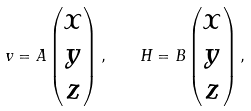<formula> <loc_0><loc_0><loc_500><loc_500>v = A \begin{pmatrix} x \\ y \\ z \end{pmatrix} , \quad H = B \begin{pmatrix} x \\ y \\ z \end{pmatrix} ,</formula> 